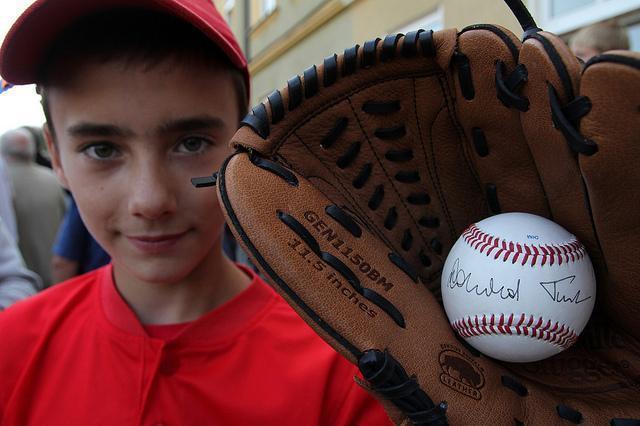How many people are visible?
Give a very brief answer. 3. How many sports balls can you see?
Give a very brief answer. 1. How many trains are there?
Give a very brief answer. 0. 